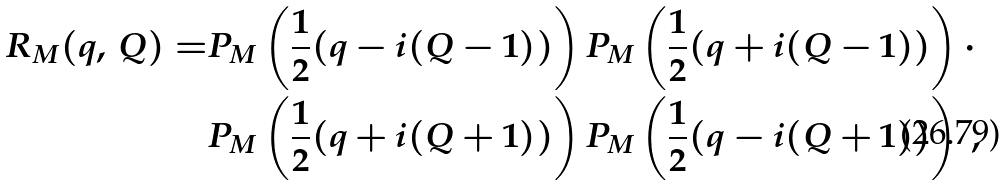Convert formula to latex. <formula><loc_0><loc_0><loc_500><loc_500>R _ { M } ( q , \, Q ) = & P _ { M } \left ( \frac { 1 } { 2 } ( q - i ( Q - 1 ) ) \right ) P _ { M } \left ( \frac { 1 } { 2 } ( q + i ( Q - 1 ) ) \right ) \cdot \\ & P _ { M } \left ( \frac { 1 } { 2 } ( q + i ( Q + 1 ) ) \right ) P _ { M } \left ( \frac { 1 } { 2 } ( q - i ( Q + 1 ) ) \right ) \ ,</formula> 